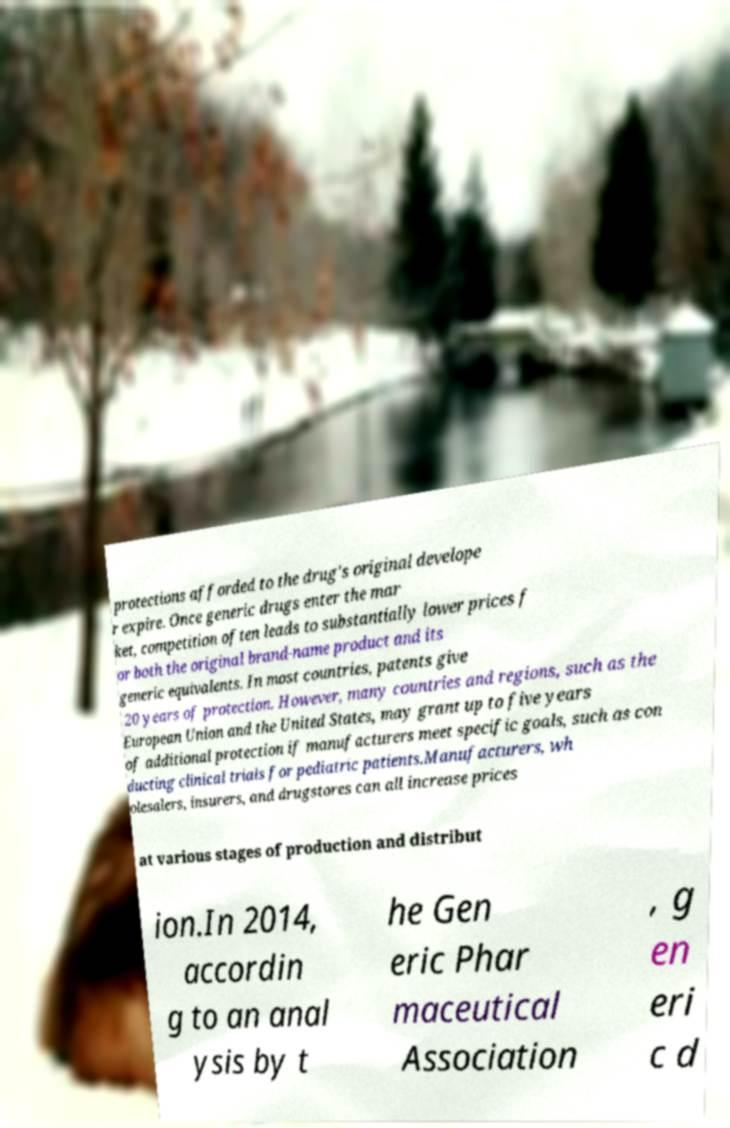Please read and relay the text visible in this image. What does it say? protections afforded to the drug's original develope r expire. Once generic drugs enter the mar ket, competition often leads to substantially lower prices f or both the original brand-name product and its generic equivalents. In most countries, patents give 20 years of protection. However, many countries and regions, such as the European Union and the United States, may grant up to five years of additional protection if manufacturers meet specific goals, such as con ducting clinical trials for pediatric patients.Manufacturers, wh olesalers, insurers, and drugstores can all increase prices at various stages of production and distribut ion.In 2014, accordin g to an anal ysis by t he Gen eric Phar maceutical Association , g en eri c d 